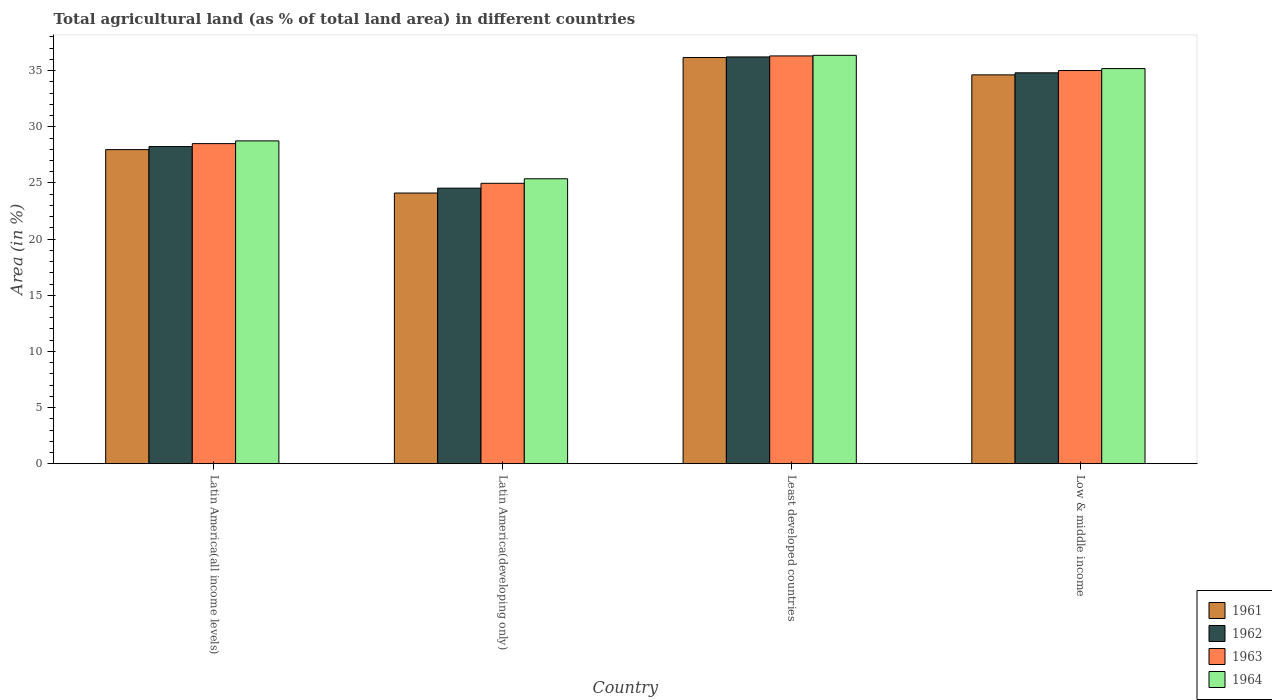Are the number of bars per tick equal to the number of legend labels?
Keep it short and to the point. Yes. What is the percentage of agricultural land in 1962 in Latin America(all income levels)?
Offer a terse response. 28.24. Across all countries, what is the maximum percentage of agricultural land in 1964?
Your answer should be very brief. 36.37. Across all countries, what is the minimum percentage of agricultural land in 1963?
Your answer should be compact. 24.97. In which country was the percentage of agricultural land in 1962 maximum?
Your answer should be very brief. Least developed countries. In which country was the percentage of agricultural land in 1964 minimum?
Provide a short and direct response. Latin America(developing only). What is the total percentage of agricultural land in 1963 in the graph?
Ensure brevity in your answer.  124.79. What is the difference between the percentage of agricultural land in 1964 in Latin America(developing only) and that in Low & middle income?
Offer a very short reply. -9.81. What is the difference between the percentage of agricultural land in 1964 in Least developed countries and the percentage of agricultural land in 1961 in Low & middle income?
Your response must be concise. 1.74. What is the average percentage of agricultural land in 1963 per country?
Make the answer very short. 31.2. What is the difference between the percentage of agricultural land of/in 1961 and percentage of agricultural land of/in 1963 in Latin America(all income levels)?
Provide a short and direct response. -0.54. What is the ratio of the percentage of agricultural land in 1963 in Latin America(developing only) to that in Least developed countries?
Offer a very short reply. 0.69. Is the percentage of agricultural land in 1964 in Latin America(all income levels) less than that in Low & middle income?
Your response must be concise. Yes. What is the difference between the highest and the second highest percentage of agricultural land in 1963?
Ensure brevity in your answer.  -1.3. What is the difference between the highest and the lowest percentage of agricultural land in 1963?
Make the answer very short. 11.34. Is the sum of the percentage of agricultural land in 1962 in Latin America(all income levels) and Least developed countries greater than the maximum percentage of agricultural land in 1963 across all countries?
Your answer should be very brief. Yes. Is it the case that in every country, the sum of the percentage of agricultural land in 1964 and percentage of agricultural land in 1962 is greater than the percentage of agricultural land in 1961?
Provide a short and direct response. Yes. How many bars are there?
Provide a short and direct response. 16. What is the difference between two consecutive major ticks on the Y-axis?
Offer a terse response. 5. Are the values on the major ticks of Y-axis written in scientific E-notation?
Make the answer very short. No. Does the graph contain grids?
Provide a succinct answer. No. How many legend labels are there?
Give a very brief answer. 4. How are the legend labels stacked?
Your answer should be very brief. Vertical. What is the title of the graph?
Give a very brief answer. Total agricultural land (as % of total land area) in different countries. Does "1991" appear as one of the legend labels in the graph?
Keep it short and to the point. No. What is the label or title of the X-axis?
Provide a succinct answer. Country. What is the label or title of the Y-axis?
Keep it short and to the point. Area (in %). What is the Area (in %) of 1961 in Latin America(all income levels)?
Your answer should be compact. 27.97. What is the Area (in %) of 1962 in Latin America(all income levels)?
Give a very brief answer. 28.24. What is the Area (in %) in 1963 in Latin America(all income levels)?
Your answer should be very brief. 28.5. What is the Area (in %) in 1964 in Latin America(all income levels)?
Give a very brief answer. 28.74. What is the Area (in %) of 1961 in Latin America(developing only)?
Make the answer very short. 24.1. What is the Area (in %) in 1962 in Latin America(developing only)?
Your response must be concise. 24.54. What is the Area (in %) of 1963 in Latin America(developing only)?
Your answer should be compact. 24.97. What is the Area (in %) in 1964 in Latin America(developing only)?
Provide a short and direct response. 25.37. What is the Area (in %) of 1961 in Least developed countries?
Keep it short and to the point. 36.17. What is the Area (in %) of 1962 in Least developed countries?
Your answer should be very brief. 36.22. What is the Area (in %) of 1963 in Least developed countries?
Offer a very short reply. 36.31. What is the Area (in %) of 1964 in Least developed countries?
Offer a very short reply. 36.37. What is the Area (in %) of 1961 in Low & middle income?
Provide a short and direct response. 34.62. What is the Area (in %) of 1962 in Low & middle income?
Your answer should be compact. 34.81. What is the Area (in %) of 1963 in Low & middle income?
Provide a short and direct response. 35.01. What is the Area (in %) of 1964 in Low & middle income?
Provide a short and direct response. 35.18. Across all countries, what is the maximum Area (in %) of 1961?
Give a very brief answer. 36.17. Across all countries, what is the maximum Area (in %) in 1962?
Your answer should be compact. 36.22. Across all countries, what is the maximum Area (in %) in 1963?
Your answer should be very brief. 36.31. Across all countries, what is the maximum Area (in %) in 1964?
Your answer should be compact. 36.37. Across all countries, what is the minimum Area (in %) in 1961?
Offer a very short reply. 24.1. Across all countries, what is the minimum Area (in %) in 1962?
Offer a terse response. 24.54. Across all countries, what is the minimum Area (in %) of 1963?
Offer a terse response. 24.97. Across all countries, what is the minimum Area (in %) of 1964?
Offer a terse response. 25.37. What is the total Area (in %) of 1961 in the graph?
Your response must be concise. 122.86. What is the total Area (in %) of 1962 in the graph?
Your answer should be compact. 123.8. What is the total Area (in %) in 1963 in the graph?
Your response must be concise. 124.79. What is the total Area (in %) in 1964 in the graph?
Offer a terse response. 125.66. What is the difference between the Area (in %) of 1961 in Latin America(all income levels) and that in Latin America(developing only)?
Offer a terse response. 3.87. What is the difference between the Area (in %) of 1962 in Latin America(all income levels) and that in Latin America(developing only)?
Ensure brevity in your answer.  3.7. What is the difference between the Area (in %) in 1963 in Latin America(all income levels) and that in Latin America(developing only)?
Keep it short and to the point. 3.53. What is the difference between the Area (in %) of 1964 in Latin America(all income levels) and that in Latin America(developing only)?
Provide a short and direct response. 3.37. What is the difference between the Area (in %) of 1961 in Latin America(all income levels) and that in Least developed countries?
Your answer should be compact. -8.2. What is the difference between the Area (in %) of 1962 in Latin America(all income levels) and that in Least developed countries?
Your answer should be very brief. -7.98. What is the difference between the Area (in %) of 1963 in Latin America(all income levels) and that in Least developed countries?
Your response must be concise. -7.81. What is the difference between the Area (in %) in 1964 in Latin America(all income levels) and that in Least developed countries?
Provide a succinct answer. -7.62. What is the difference between the Area (in %) of 1961 in Latin America(all income levels) and that in Low & middle income?
Offer a very short reply. -6.66. What is the difference between the Area (in %) of 1962 in Latin America(all income levels) and that in Low & middle income?
Give a very brief answer. -6.57. What is the difference between the Area (in %) in 1963 in Latin America(all income levels) and that in Low & middle income?
Keep it short and to the point. -6.51. What is the difference between the Area (in %) of 1964 in Latin America(all income levels) and that in Low & middle income?
Provide a succinct answer. -6.44. What is the difference between the Area (in %) of 1961 in Latin America(developing only) and that in Least developed countries?
Make the answer very short. -12.07. What is the difference between the Area (in %) of 1962 in Latin America(developing only) and that in Least developed countries?
Make the answer very short. -11.68. What is the difference between the Area (in %) in 1963 in Latin America(developing only) and that in Least developed countries?
Your answer should be very brief. -11.34. What is the difference between the Area (in %) of 1964 in Latin America(developing only) and that in Least developed countries?
Keep it short and to the point. -10.99. What is the difference between the Area (in %) of 1961 in Latin America(developing only) and that in Low & middle income?
Provide a short and direct response. -10.52. What is the difference between the Area (in %) in 1962 in Latin America(developing only) and that in Low & middle income?
Ensure brevity in your answer.  -10.27. What is the difference between the Area (in %) of 1963 in Latin America(developing only) and that in Low & middle income?
Keep it short and to the point. -10.04. What is the difference between the Area (in %) of 1964 in Latin America(developing only) and that in Low & middle income?
Your response must be concise. -9.81. What is the difference between the Area (in %) of 1961 in Least developed countries and that in Low & middle income?
Provide a succinct answer. 1.54. What is the difference between the Area (in %) in 1962 in Least developed countries and that in Low & middle income?
Provide a short and direct response. 1.42. What is the difference between the Area (in %) of 1963 in Least developed countries and that in Low & middle income?
Provide a succinct answer. 1.3. What is the difference between the Area (in %) in 1964 in Least developed countries and that in Low & middle income?
Your answer should be very brief. 1.19. What is the difference between the Area (in %) in 1961 in Latin America(all income levels) and the Area (in %) in 1962 in Latin America(developing only)?
Provide a succinct answer. 3.43. What is the difference between the Area (in %) of 1961 in Latin America(all income levels) and the Area (in %) of 1963 in Latin America(developing only)?
Your answer should be very brief. 3. What is the difference between the Area (in %) in 1961 in Latin America(all income levels) and the Area (in %) in 1964 in Latin America(developing only)?
Make the answer very short. 2.6. What is the difference between the Area (in %) in 1962 in Latin America(all income levels) and the Area (in %) in 1963 in Latin America(developing only)?
Your answer should be compact. 3.27. What is the difference between the Area (in %) of 1962 in Latin America(all income levels) and the Area (in %) of 1964 in Latin America(developing only)?
Provide a short and direct response. 2.87. What is the difference between the Area (in %) of 1963 in Latin America(all income levels) and the Area (in %) of 1964 in Latin America(developing only)?
Ensure brevity in your answer.  3.13. What is the difference between the Area (in %) in 1961 in Latin America(all income levels) and the Area (in %) in 1962 in Least developed countries?
Offer a terse response. -8.25. What is the difference between the Area (in %) of 1961 in Latin America(all income levels) and the Area (in %) of 1963 in Least developed countries?
Make the answer very short. -8.34. What is the difference between the Area (in %) of 1961 in Latin America(all income levels) and the Area (in %) of 1964 in Least developed countries?
Your answer should be compact. -8.4. What is the difference between the Area (in %) of 1962 in Latin America(all income levels) and the Area (in %) of 1963 in Least developed countries?
Offer a very short reply. -8.07. What is the difference between the Area (in %) of 1962 in Latin America(all income levels) and the Area (in %) of 1964 in Least developed countries?
Offer a terse response. -8.13. What is the difference between the Area (in %) in 1963 in Latin America(all income levels) and the Area (in %) in 1964 in Least developed countries?
Offer a terse response. -7.86. What is the difference between the Area (in %) in 1961 in Latin America(all income levels) and the Area (in %) in 1962 in Low & middle income?
Your response must be concise. -6.84. What is the difference between the Area (in %) of 1961 in Latin America(all income levels) and the Area (in %) of 1963 in Low & middle income?
Ensure brevity in your answer.  -7.04. What is the difference between the Area (in %) in 1961 in Latin America(all income levels) and the Area (in %) in 1964 in Low & middle income?
Provide a short and direct response. -7.21. What is the difference between the Area (in %) in 1962 in Latin America(all income levels) and the Area (in %) in 1963 in Low & middle income?
Your answer should be very brief. -6.77. What is the difference between the Area (in %) in 1962 in Latin America(all income levels) and the Area (in %) in 1964 in Low & middle income?
Keep it short and to the point. -6.94. What is the difference between the Area (in %) of 1963 in Latin America(all income levels) and the Area (in %) of 1964 in Low & middle income?
Offer a terse response. -6.68. What is the difference between the Area (in %) of 1961 in Latin America(developing only) and the Area (in %) of 1962 in Least developed countries?
Ensure brevity in your answer.  -12.12. What is the difference between the Area (in %) in 1961 in Latin America(developing only) and the Area (in %) in 1963 in Least developed countries?
Ensure brevity in your answer.  -12.21. What is the difference between the Area (in %) in 1961 in Latin America(developing only) and the Area (in %) in 1964 in Least developed countries?
Provide a succinct answer. -12.26. What is the difference between the Area (in %) of 1962 in Latin America(developing only) and the Area (in %) of 1963 in Least developed countries?
Ensure brevity in your answer.  -11.77. What is the difference between the Area (in %) of 1962 in Latin America(developing only) and the Area (in %) of 1964 in Least developed countries?
Give a very brief answer. -11.83. What is the difference between the Area (in %) in 1963 in Latin America(developing only) and the Area (in %) in 1964 in Least developed countries?
Offer a very short reply. -11.4. What is the difference between the Area (in %) in 1961 in Latin America(developing only) and the Area (in %) in 1962 in Low & middle income?
Offer a terse response. -10.7. What is the difference between the Area (in %) in 1961 in Latin America(developing only) and the Area (in %) in 1963 in Low & middle income?
Give a very brief answer. -10.91. What is the difference between the Area (in %) in 1961 in Latin America(developing only) and the Area (in %) in 1964 in Low & middle income?
Give a very brief answer. -11.08. What is the difference between the Area (in %) of 1962 in Latin America(developing only) and the Area (in %) of 1963 in Low & middle income?
Your answer should be very brief. -10.47. What is the difference between the Area (in %) in 1962 in Latin America(developing only) and the Area (in %) in 1964 in Low & middle income?
Your response must be concise. -10.64. What is the difference between the Area (in %) of 1963 in Latin America(developing only) and the Area (in %) of 1964 in Low & middle income?
Your answer should be compact. -10.21. What is the difference between the Area (in %) in 1961 in Least developed countries and the Area (in %) in 1962 in Low & middle income?
Ensure brevity in your answer.  1.36. What is the difference between the Area (in %) in 1961 in Least developed countries and the Area (in %) in 1963 in Low & middle income?
Provide a succinct answer. 1.16. What is the difference between the Area (in %) in 1961 in Least developed countries and the Area (in %) in 1964 in Low & middle income?
Your answer should be compact. 0.99. What is the difference between the Area (in %) in 1962 in Least developed countries and the Area (in %) in 1963 in Low & middle income?
Ensure brevity in your answer.  1.21. What is the difference between the Area (in %) in 1962 in Least developed countries and the Area (in %) in 1964 in Low & middle income?
Your answer should be very brief. 1.04. What is the difference between the Area (in %) of 1963 in Least developed countries and the Area (in %) of 1964 in Low & middle income?
Provide a short and direct response. 1.13. What is the average Area (in %) in 1961 per country?
Make the answer very short. 30.72. What is the average Area (in %) of 1962 per country?
Your response must be concise. 30.95. What is the average Area (in %) of 1963 per country?
Offer a very short reply. 31.2. What is the average Area (in %) in 1964 per country?
Offer a very short reply. 31.42. What is the difference between the Area (in %) in 1961 and Area (in %) in 1962 in Latin America(all income levels)?
Provide a succinct answer. -0.27. What is the difference between the Area (in %) in 1961 and Area (in %) in 1963 in Latin America(all income levels)?
Offer a terse response. -0.54. What is the difference between the Area (in %) of 1961 and Area (in %) of 1964 in Latin America(all income levels)?
Offer a very short reply. -0.78. What is the difference between the Area (in %) in 1962 and Area (in %) in 1963 in Latin America(all income levels)?
Your response must be concise. -0.26. What is the difference between the Area (in %) of 1962 and Area (in %) of 1964 in Latin America(all income levels)?
Provide a short and direct response. -0.51. What is the difference between the Area (in %) of 1963 and Area (in %) of 1964 in Latin America(all income levels)?
Offer a very short reply. -0.24. What is the difference between the Area (in %) in 1961 and Area (in %) in 1962 in Latin America(developing only)?
Keep it short and to the point. -0.43. What is the difference between the Area (in %) in 1961 and Area (in %) in 1963 in Latin America(developing only)?
Provide a short and direct response. -0.87. What is the difference between the Area (in %) of 1961 and Area (in %) of 1964 in Latin America(developing only)?
Provide a succinct answer. -1.27. What is the difference between the Area (in %) of 1962 and Area (in %) of 1963 in Latin America(developing only)?
Offer a terse response. -0.43. What is the difference between the Area (in %) of 1962 and Area (in %) of 1964 in Latin America(developing only)?
Give a very brief answer. -0.84. What is the difference between the Area (in %) of 1963 and Area (in %) of 1964 in Latin America(developing only)?
Keep it short and to the point. -0.4. What is the difference between the Area (in %) of 1961 and Area (in %) of 1962 in Least developed countries?
Give a very brief answer. -0.05. What is the difference between the Area (in %) of 1961 and Area (in %) of 1963 in Least developed countries?
Your response must be concise. -0.14. What is the difference between the Area (in %) in 1961 and Area (in %) in 1964 in Least developed countries?
Make the answer very short. -0.2. What is the difference between the Area (in %) of 1962 and Area (in %) of 1963 in Least developed countries?
Offer a terse response. -0.09. What is the difference between the Area (in %) of 1962 and Area (in %) of 1964 in Least developed countries?
Your answer should be compact. -0.15. What is the difference between the Area (in %) in 1963 and Area (in %) in 1964 in Least developed countries?
Make the answer very short. -0.06. What is the difference between the Area (in %) in 1961 and Area (in %) in 1962 in Low & middle income?
Ensure brevity in your answer.  -0.18. What is the difference between the Area (in %) of 1961 and Area (in %) of 1963 in Low & middle income?
Ensure brevity in your answer.  -0.39. What is the difference between the Area (in %) in 1961 and Area (in %) in 1964 in Low & middle income?
Ensure brevity in your answer.  -0.56. What is the difference between the Area (in %) of 1962 and Area (in %) of 1963 in Low & middle income?
Make the answer very short. -0.2. What is the difference between the Area (in %) in 1962 and Area (in %) in 1964 in Low & middle income?
Keep it short and to the point. -0.38. What is the difference between the Area (in %) of 1963 and Area (in %) of 1964 in Low & middle income?
Your answer should be very brief. -0.17. What is the ratio of the Area (in %) in 1961 in Latin America(all income levels) to that in Latin America(developing only)?
Your answer should be very brief. 1.16. What is the ratio of the Area (in %) of 1962 in Latin America(all income levels) to that in Latin America(developing only)?
Your answer should be very brief. 1.15. What is the ratio of the Area (in %) in 1963 in Latin America(all income levels) to that in Latin America(developing only)?
Offer a terse response. 1.14. What is the ratio of the Area (in %) of 1964 in Latin America(all income levels) to that in Latin America(developing only)?
Offer a very short reply. 1.13. What is the ratio of the Area (in %) in 1961 in Latin America(all income levels) to that in Least developed countries?
Provide a short and direct response. 0.77. What is the ratio of the Area (in %) of 1962 in Latin America(all income levels) to that in Least developed countries?
Keep it short and to the point. 0.78. What is the ratio of the Area (in %) of 1963 in Latin America(all income levels) to that in Least developed countries?
Keep it short and to the point. 0.79. What is the ratio of the Area (in %) of 1964 in Latin America(all income levels) to that in Least developed countries?
Provide a short and direct response. 0.79. What is the ratio of the Area (in %) of 1961 in Latin America(all income levels) to that in Low & middle income?
Provide a short and direct response. 0.81. What is the ratio of the Area (in %) in 1962 in Latin America(all income levels) to that in Low & middle income?
Keep it short and to the point. 0.81. What is the ratio of the Area (in %) in 1963 in Latin America(all income levels) to that in Low & middle income?
Your answer should be very brief. 0.81. What is the ratio of the Area (in %) in 1964 in Latin America(all income levels) to that in Low & middle income?
Your answer should be very brief. 0.82. What is the ratio of the Area (in %) in 1961 in Latin America(developing only) to that in Least developed countries?
Make the answer very short. 0.67. What is the ratio of the Area (in %) in 1962 in Latin America(developing only) to that in Least developed countries?
Provide a short and direct response. 0.68. What is the ratio of the Area (in %) of 1963 in Latin America(developing only) to that in Least developed countries?
Offer a terse response. 0.69. What is the ratio of the Area (in %) in 1964 in Latin America(developing only) to that in Least developed countries?
Your response must be concise. 0.7. What is the ratio of the Area (in %) in 1961 in Latin America(developing only) to that in Low & middle income?
Give a very brief answer. 0.7. What is the ratio of the Area (in %) of 1962 in Latin America(developing only) to that in Low & middle income?
Your answer should be compact. 0.7. What is the ratio of the Area (in %) of 1963 in Latin America(developing only) to that in Low & middle income?
Give a very brief answer. 0.71. What is the ratio of the Area (in %) in 1964 in Latin America(developing only) to that in Low & middle income?
Ensure brevity in your answer.  0.72. What is the ratio of the Area (in %) in 1961 in Least developed countries to that in Low & middle income?
Your answer should be very brief. 1.04. What is the ratio of the Area (in %) in 1962 in Least developed countries to that in Low & middle income?
Make the answer very short. 1.04. What is the ratio of the Area (in %) of 1963 in Least developed countries to that in Low & middle income?
Offer a terse response. 1.04. What is the ratio of the Area (in %) in 1964 in Least developed countries to that in Low & middle income?
Keep it short and to the point. 1.03. What is the difference between the highest and the second highest Area (in %) of 1961?
Offer a very short reply. 1.54. What is the difference between the highest and the second highest Area (in %) of 1962?
Your response must be concise. 1.42. What is the difference between the highest and the second highest Area (in %) of 1963?
Your response must be concise. 1.3. What is the difference between the highest and the second highest Area (in %) of 1964?
Ensure brevity in your answer.  1.19. What is the difference between the highest and the lowest Area (in %) in 1961?
Your answer should be very brief. 12.07. What is the difference between the highest and the lowest Area (in %) of 1962?
Provide a succinct answer. 11.68. What is the difference between the highest and the lowest Area (in %) in 1963?
Provide a succinct answer. 11.34. What is the difference between the highest and the lowest Area (in %) in 1964?
Your answer should be compact. 10.99. 